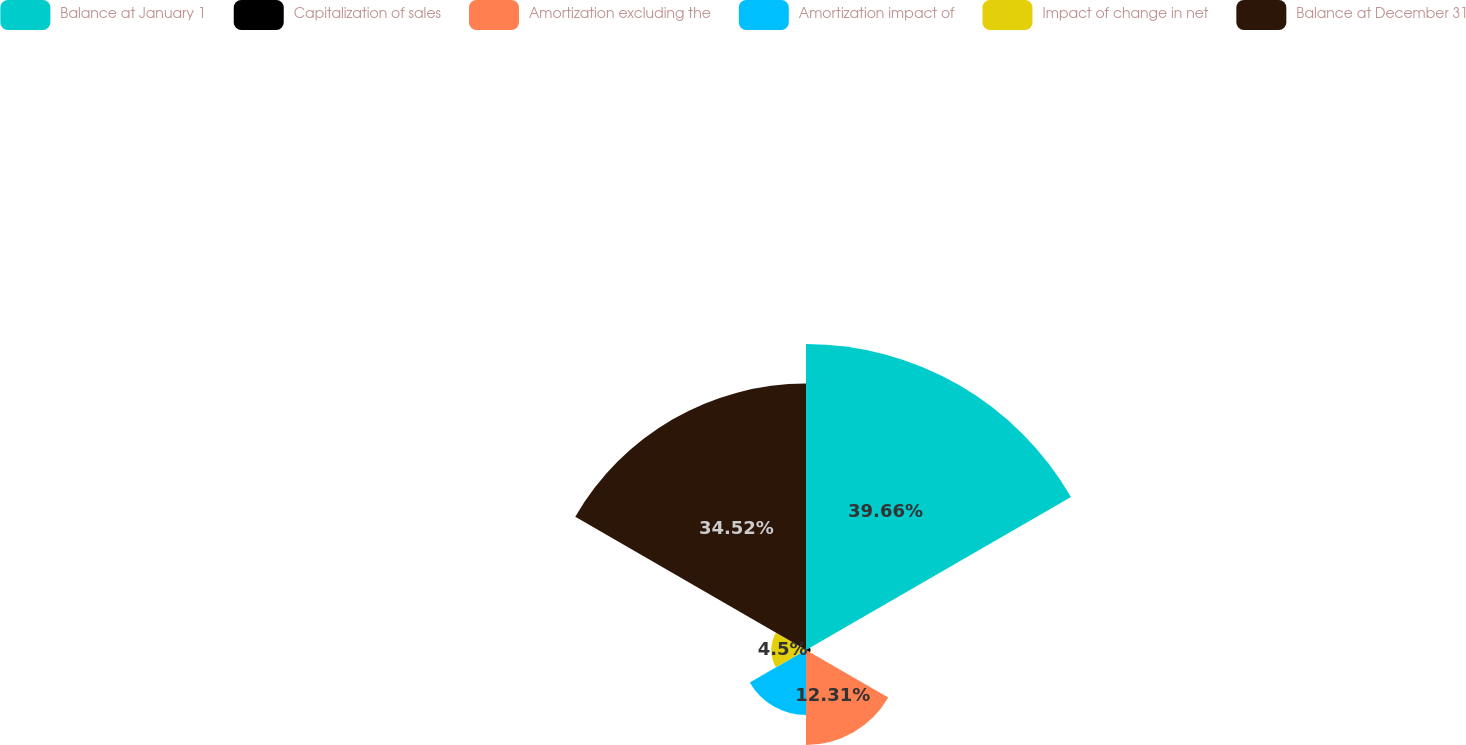<chart> <loc_0><loc_0><loc_500><loc_500><pie_chart><fcel>Balance at January 1<fcel>Capitalization of sales<fcel>Amortization excluding the<fcel>Amortization impact of<fcel>Impact of change in net<fcel>Balance at December 31<nl><fcel>39.65%<fcel>0.6%<fcel>12.31%<fcel>8.41%<fcel>4.5%<fcel>34.52%<nl></chart> 